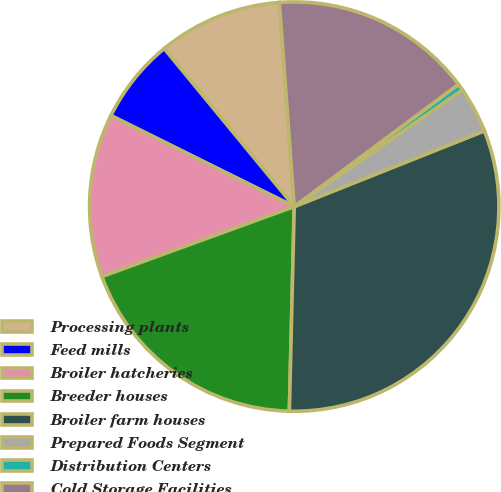Convert chart to OTSL. <chart><loc_0><loc_0><loc_500><loc_500><pie_chart><fcel>Processing plants<fcel>Feed mills<fcel>Broiler hatcheries<fcel>Breeder houses<fcel>Broiler farm houses<fcel>Prepared Foods Segment<fcel>Distribution Centers<fcel>Cold Storage Facilities<nl><fcel>9.8%<fcel>6.71%<fcel>12.89%<fcel>19.07%<fcel>31.42%<fcel>3.62%<fcel>0.53%<fcel>15.98%<nl></chart> 